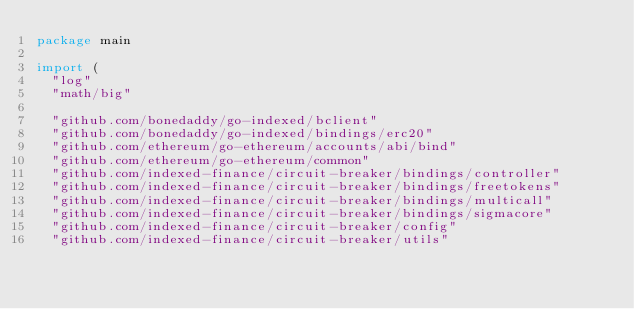<code> <loc_0><loc_0><loc_500><loc_500><_Go_>package main

import (
	"log"
	"math/big"

	"github.com/bonedaddy/go-indexed/bclient"
	"github.com/bonedaddy/go-indexed/bindings/erc20"
	"github.com/ethereum/go-ethereum/accounts/abi/bind"
	"github.com/ethereum/go-ethereum/common"
	"github.com/indexed-finance/circuit-breaker/bindings/controller"
	"github.com/indexed-finance/circuit-breaker/bindings/freetokens"
	"github.com/indexed-finance/circuit-breaker/bindings/multicall"
	"github.com/indexed-finance/circuit-breaker/bindings/sigmacore"
	"github.com/indexed-finance/circuit-breaker/config"
	"github.com/indexed-finance/circuit-breaker/utils"</code> 